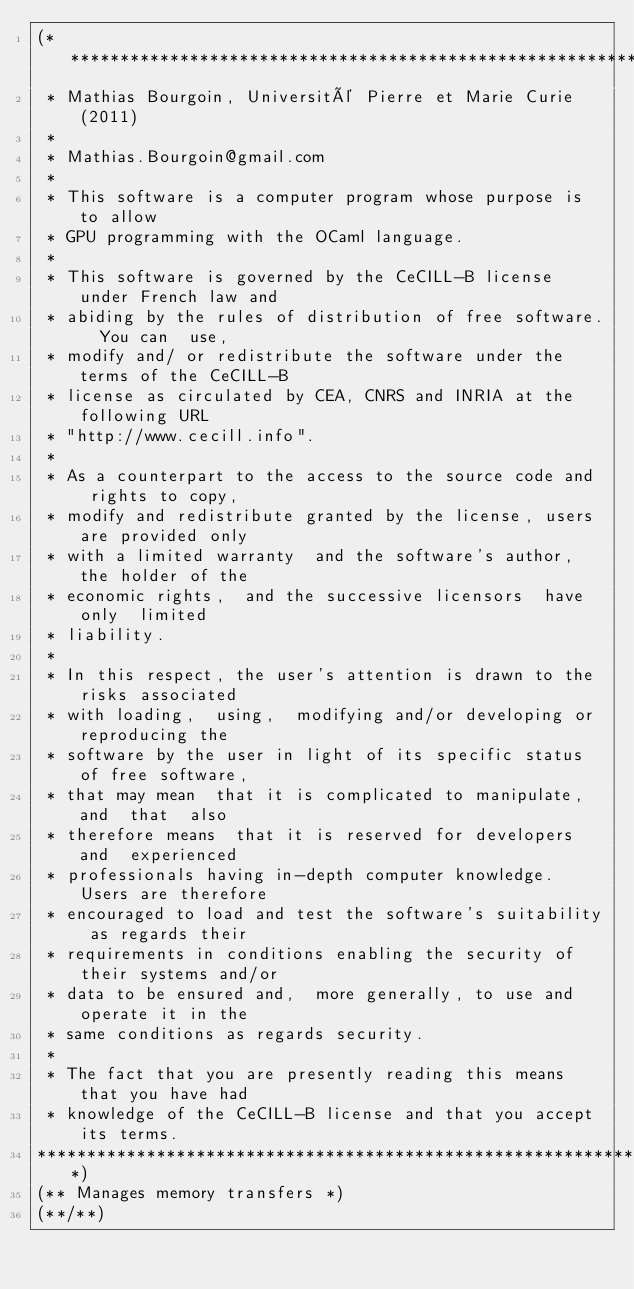Convert code to text. <code><loc_0><loc_0><loc_500><loc_500><_OCaml_>(******************************************************************************
 * Mathias Bourgoin, Université Pierre et Marie Curie (2011)
 *
 * Mathias.Bourgoin@gmail.com
 *
 * This software is a computer program whose purpose is to allow
 * GPU programming with the OCaml language.
 *
 * This software is governed by the CeCILL-B license under French law and
 * abiding by the rules of distribution of free software.  You can  use, 
 * modify and/ or redistribute the software under the terms of the CeCILL-B
 * license as circulated by CEA, CNRS and INRIA at the following URL
 * "http://www.cecill.info". 
 * 
 * As a counterpart to the access to the source code and  rights to copy,
 * modify and redistribute granted by the license, users are provided only
 * with a limited warranty  and the software's author,  the holder of the
 * economic rights,  and the successive licensors  have only  limited
 * liability. 
 * 
 * In this respect, the user's attention is drawn to the risks associated
 * with loading,  using,  modifying and/or developing or reproducing the
 * software by the user in light of its specific status of free software,
 * that may mean  that it is complicated to manipulate,  and  that  also
 * therefore means  that it is reserved for developers  and  experienced
 * professionals having in-depth computer knowledge. Users are therefore
 * encouraged to load and test the software's suitability as regards their
 * requirements in conditions enabling the security of their systems and/or 
 * data to be ensured and,  more generally, to use and operate it in the 
 * same conditions as regards security. 
 * 
 * The fact that you are presently reading this means that you have had
 * knowledge of the CeCILL-B license and that you accept its terms.
*******************************************************************************)
(** Manages memory transfers *)
(**/**)</code> 